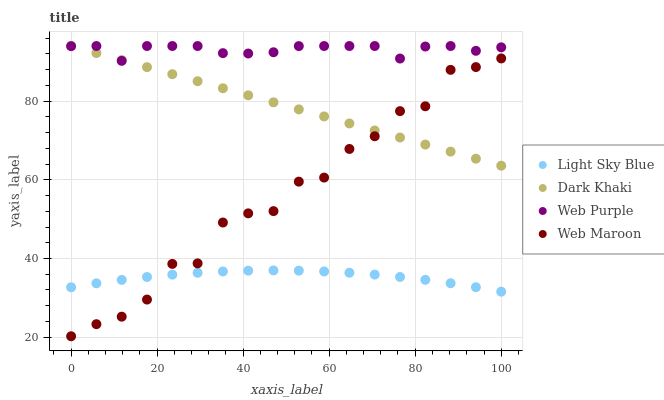Does Light Sky Blue have the minimum area under the curve?
Answer yes or no. Yes. Does Web Purple have the maximum area under the curve?
Answer yes or no. Yes. Does Web Purple have the minimum area under the curve?
Answer yes or no. No. Does Light Sky Blue have the maximum area under the curve?
Answer yes or no. No. Is Dark Khaki the smoothest?
Answer yes or no. Yes. Is Web Maroon the roughest?
Answer yes or no. Yes. Is Web Purple the smoothest?
Answer yes or no. No. Is Web Purple the roughest?
Answer yes or no. No. Does Web Maroon have the lowest value?
Answer yes or no. Yes. Does Light Sky Blue have the lowest value?
Answer yes or no. No. Does Web Purple have the highest value?
Answer yes or no. Yes. Does Light Sky Blue have the highest value?
Answer yes or no. No. Is Light Sky Blue less than Web Purple?
Answer yes or no. Yes. Is Web Purple greater than Light Sky Blue?
Answer yes or no. Yes. Does Dark Khaki intersect Web Maroon?
Answer yes or no. Yes. Is Dark Khaki less than Web Maroon?
Answer yes or no. No. Is Dark Khaki greater than Web Maroon?
Answer yes or no. No. Does Light Sky Blue intersect Web Purple?
Answer yes or no. No. 